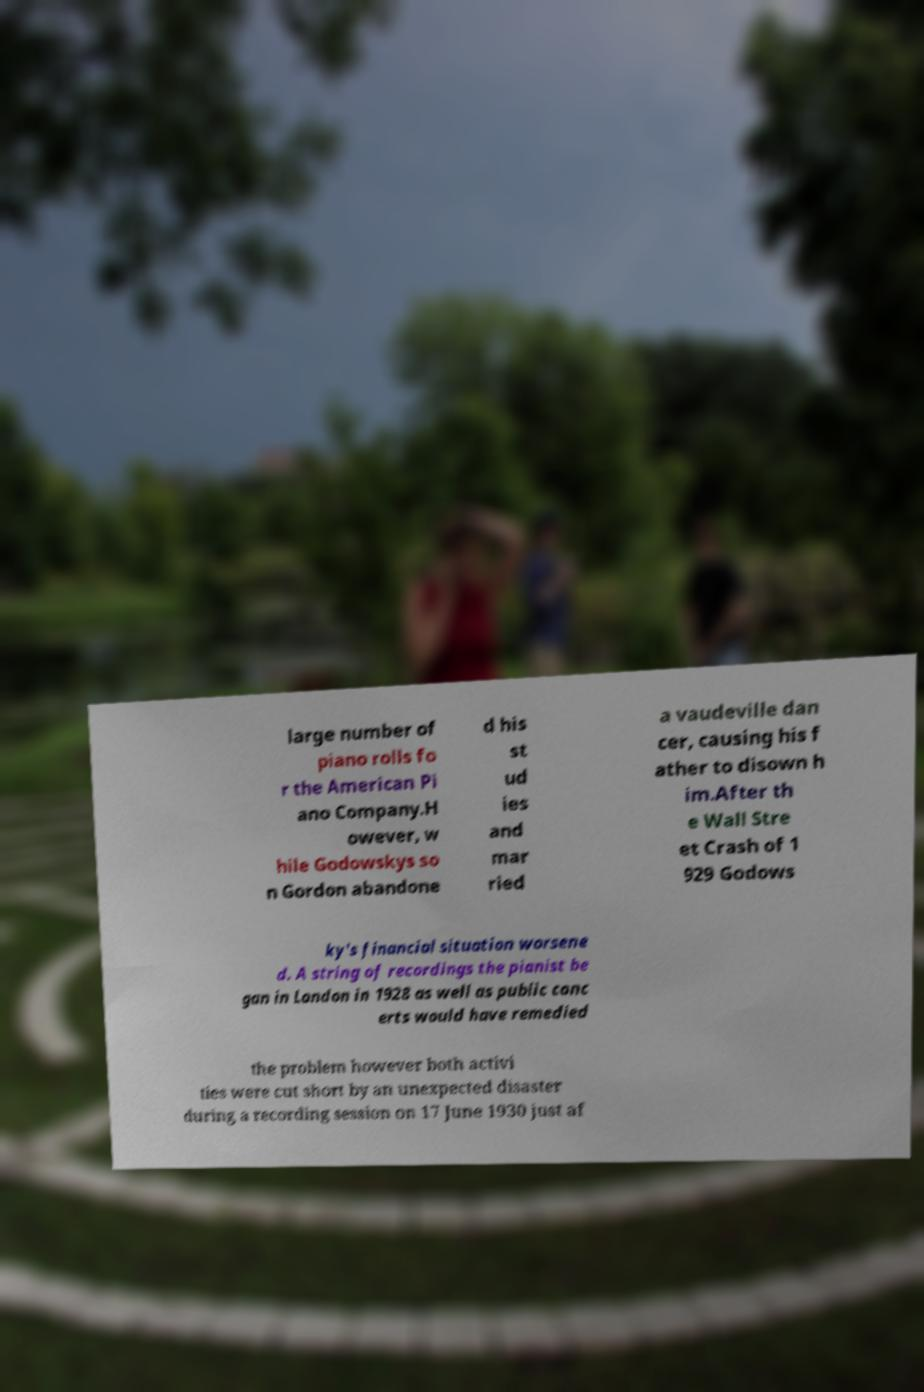Could you extract and type out the text from this image? large number of piano rolls fo r the American Pi ano Company.H owever, w hile Godowskys so n Gordon abandone d his st ud ies and mar ried a vaudeville dan cer, causing his f ather to disown h im.After th e Wall Stre et Crash of 1 929 Godows ky's financial situation worsene d. A string of recordings the pianist be gan in London in 1928 as well as public conc erts would have remedied the problem however both activi ties were cut short by an unexpected disaster during a recording session on 17 June 1930 just af 